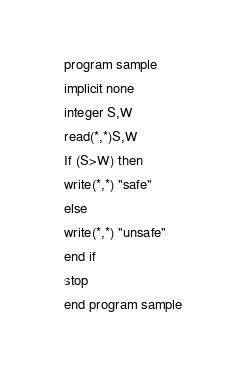<code> <loc_0><loc_0><loc_500><loc_500><_FORTRAN_>program sample
implicit none
integer S,W
read(*,*)S,W
If (S>W) then
write(*,*) "safe"
else
write(*,*) "unsafe"
end if
stop
end program sample
</code> 